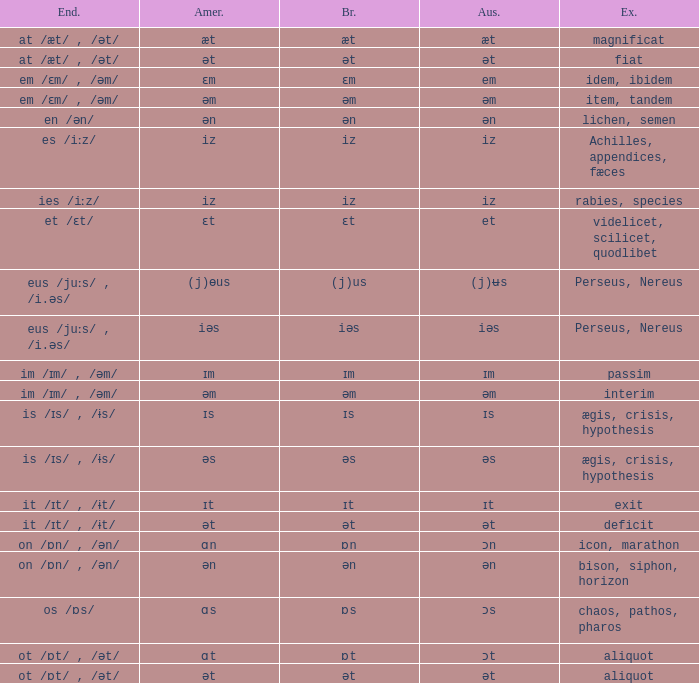Which British has Examples of exit? Ɪt. 